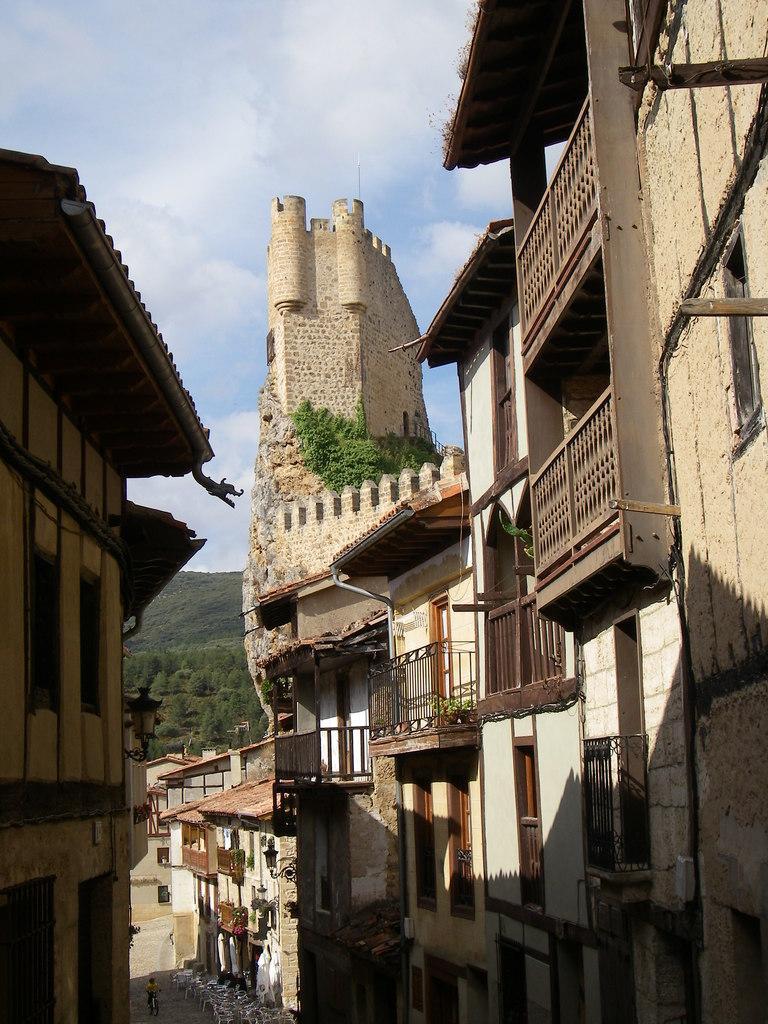In one or two sentences, can you explain what this image depicts? In this picture there are buildings and trees and there is a light on the building. At the bottom there is a person and their might be tables and chairs. At the top there is sky and there are clouds. 